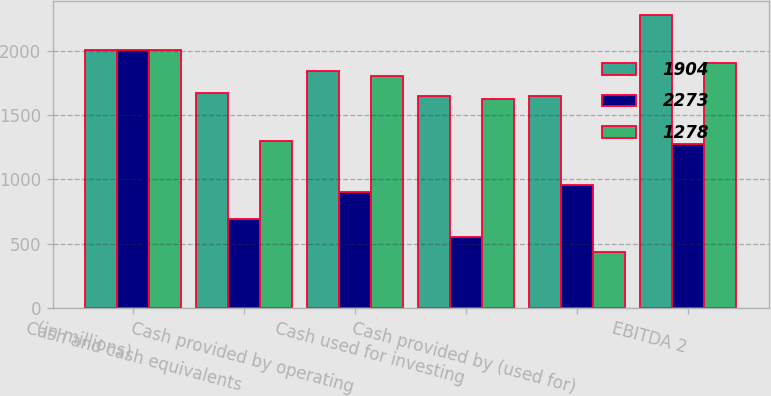<chart> <loc_0><loc_0><loc_500><loc_500><stacked_bar_chart><ecel><fcel>(in millions)<fcel>Cash and cash equivalents<fcel>Cash provided by operating<fcel>Cash used for investing<fcel>Cash provided by (used for)<fcel>EBITDA 2<nl><fcel>1904<fcel>2006<fcel>1668<fcel>1845<fcel>1645<fcel>1645<fcel>2273<nl><fcel>2273<fcel>2005<fcel>689<fcel>903<fcel>551<fcel>954<fcel>1278<nl><fcel>1278<fcel>2004<fcel>1296<fcel>1804<fcel>1622<fcel>439<fcel>1904<nl></chart> 